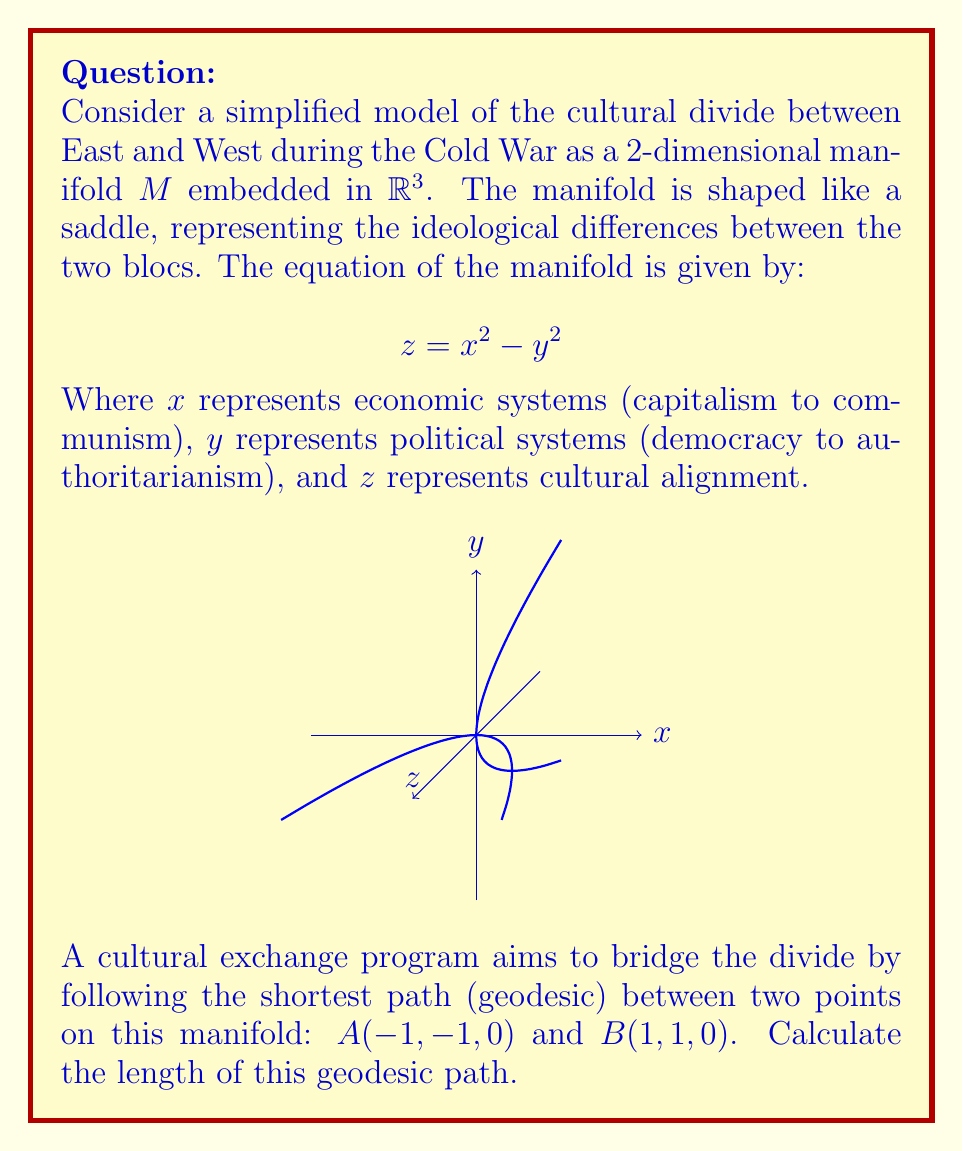Solve this math problem. To solve this problem, we'll follow these steps:

1) First, we need to understand that the geodesic on this manifold is not a straight line in $\mathbb{R}^3$, but the shortest path along the surface.

2) For a surface defined by $z = f(x,y)$, the length of a curve $\gamma(t) = (x(t), y(t), z(t))$ from $t=a$ to $t=b$ is given by:

   $$L = \int_a^b \sqrt{(1+f_x^2)(\frac{dx}{dt})^2 + (1+f_y^2)(\frac{dy}{dt})^2 + 2f_xf_y\frac{dx}{dt}\frac{dy}{dt}} dt$$

   Where $f_x = \frac{\partial f}{\partial x}$ and $f_y = \frac{\partial f}{\partial y}$.

3) In our case, $f(x,y) = x^2 - y^2$, so $f_x = 2x$ and $f_y = -2y$.

4) Substituting these into our length formula:

   $$L = \int_a^b \sqrt{(1+4x^2)(\frac{dx}{dt})^2 + (1+4y^2)(\frac{dy}{dt})^2 - 8xy\frac{dx}{dt}\frac{dy}{dt}} dt$$

5) To simplify, let's parameterize our path linearly:
   $x(t) = -1 + 2t$, $y(t) = -1 + 2t$, where $0 \leq t \leq 1$

6) Then $\frac{dx}{dt} = \frac{dy}{dt} = 2$

7) Substituting into our integral:

   $$L = \int_0^1 \sqrt{(1+4(-1+2t)^2)4 + (1+4(-1+2t)^2)4 - 8(-1+2t)^2 \cdot 4} dt$$

8) Simplifying:

   $$L = \int_0^1 \sqrt{8(1+4(-1+2t)^2) - 32(-1+2t)^2} dt$$
   $$= \int_0^1 \sqrt{8 + 32(-1+2t)^2 - 32(-1+2t)^2} dt$$
   $$= \int_0^1 \sqrt{8} dt = 2\sqrt{2}$$

Therefore, the length of the geodesic path is $2\sqrt{2}$.
Answer: $2\sqrt{2}$ 